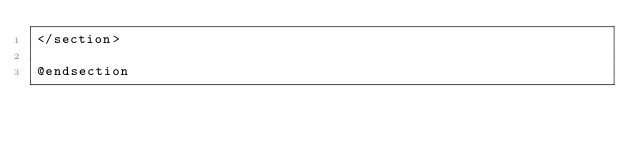<code> <loc_0><loc_0><loc_500><loc_500><_PHP_></section>

@endsection
</code> 